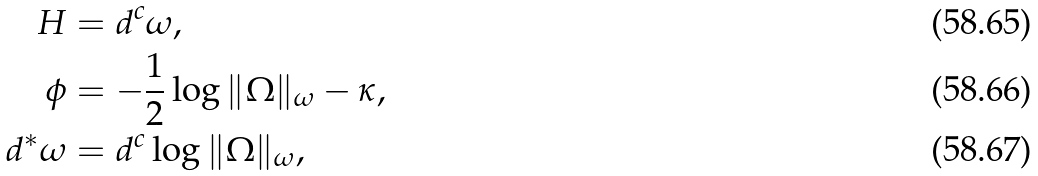<formula> <loc_0><loc_0><loc_500><loc_500>H & = d ^ { c } \omega , \\ \phi & = - \frac { 1 } { 2 } \log \| \Omega \| _ { \omega } - \kappa , \\ d ^ { * } \omega & = d ^ { c } \log \| \Omega \| _ { \omega } ,</formula> 